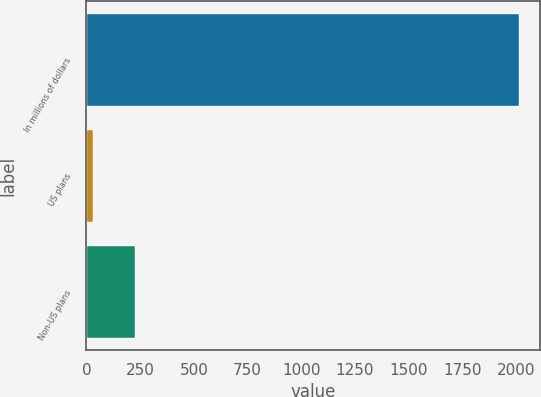Convert chart to OTSL. <chart><loc_0><loc_0><loc_500><loc_500><bar_chart><fcel>In millions of dollars<fcel>US plans<fcel>Non-US plans<nl><fcel>2014<fcel>28<fcel>226.6<nl></chart> 